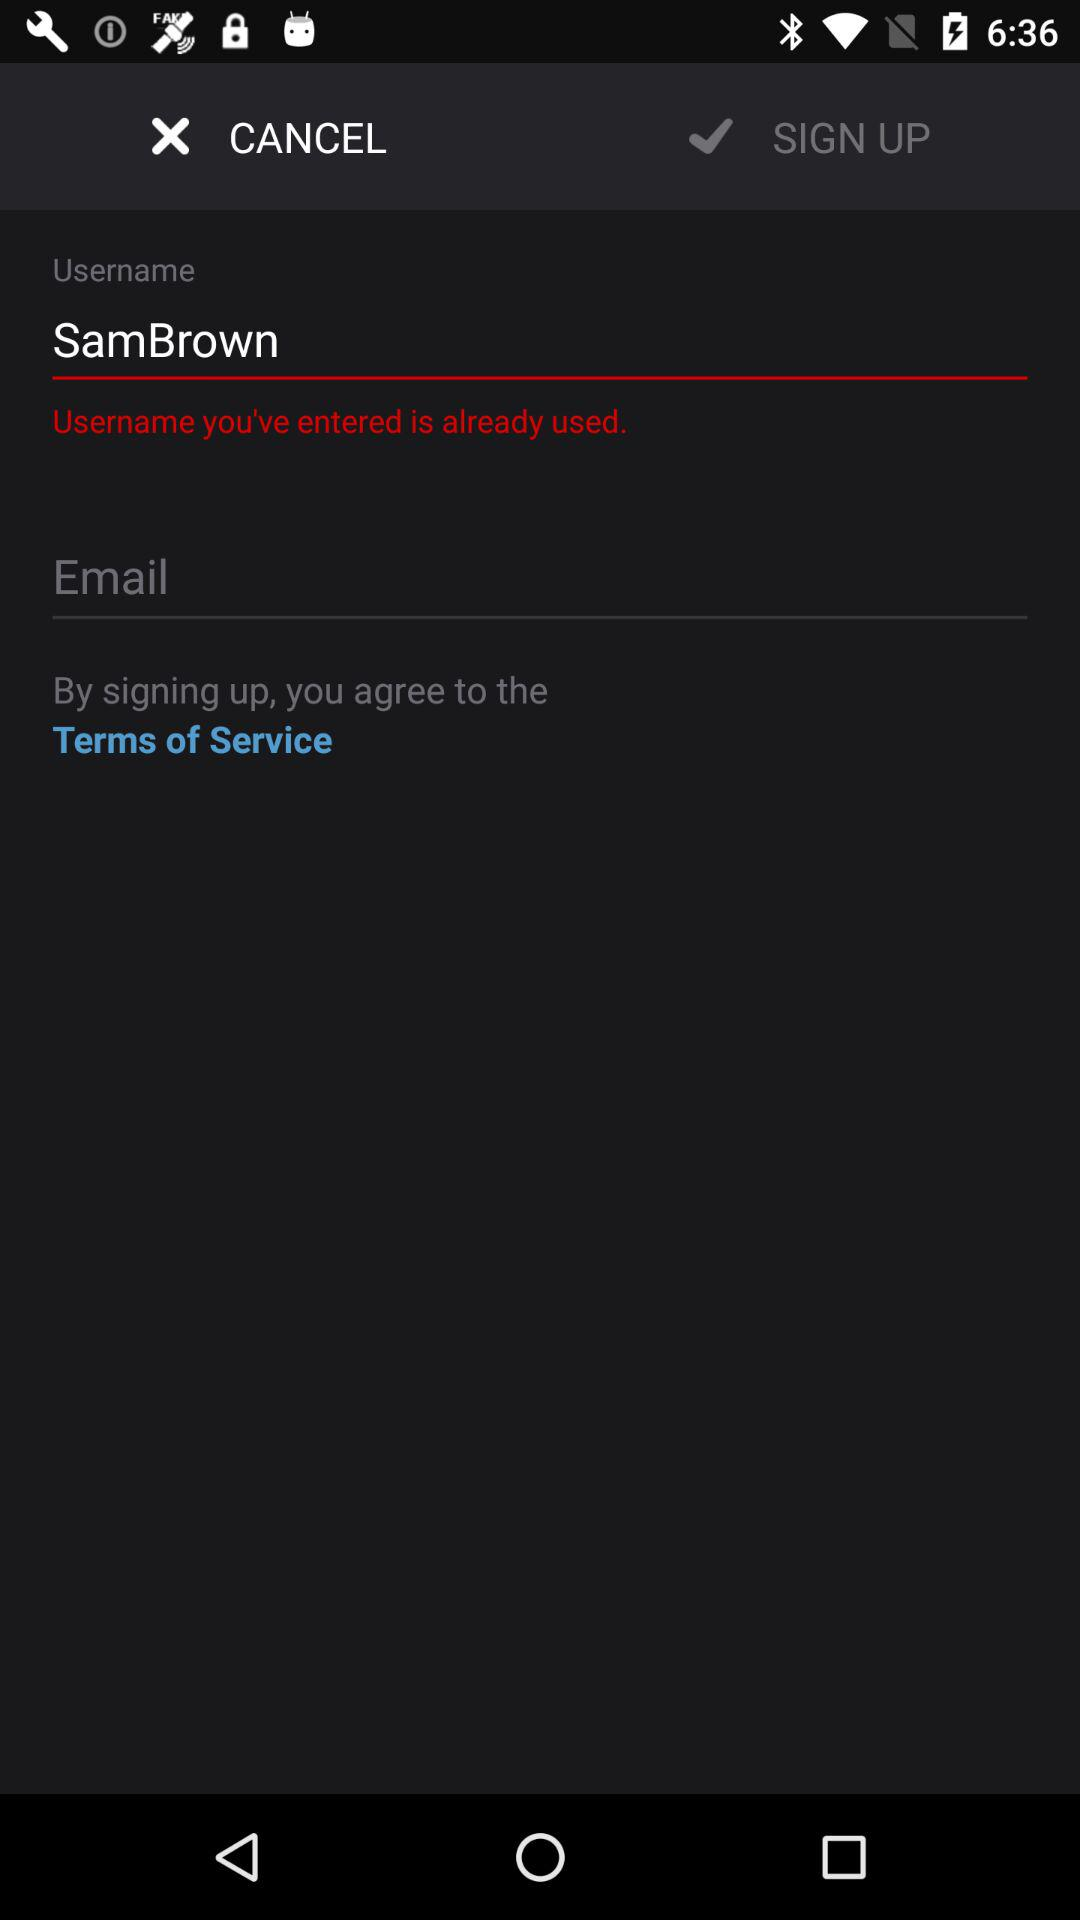What is the username? The username is "SamBrown". 